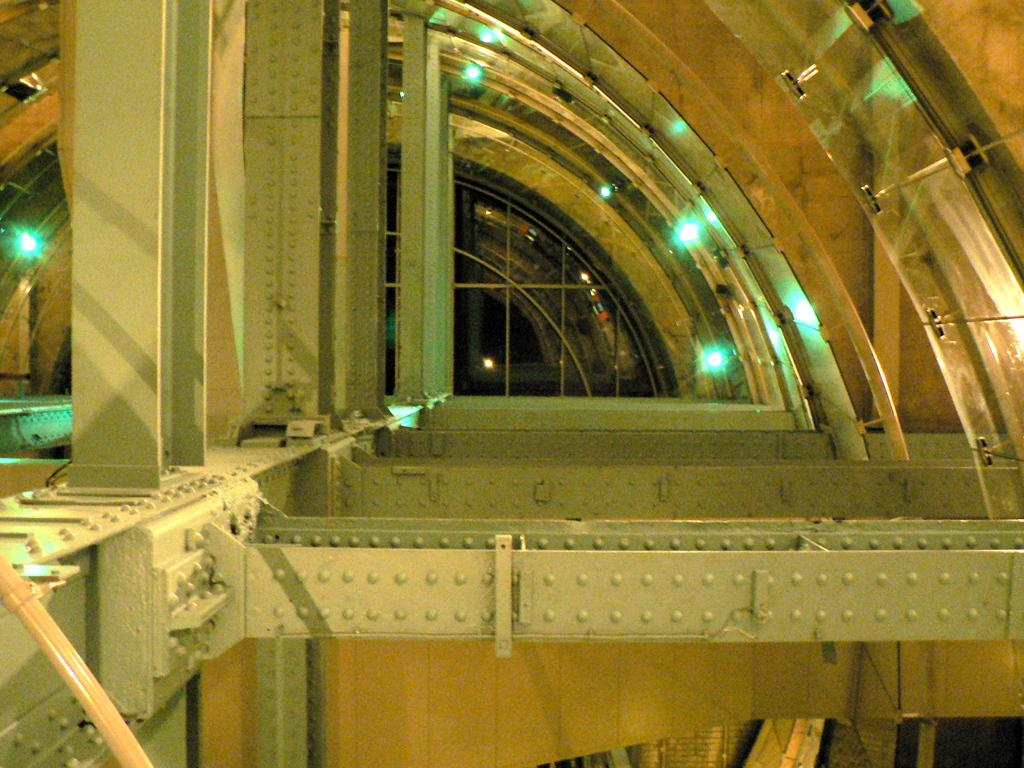Where was the image taken? The image was taken inside a metal chamber. What can be seen in the middle of the chamber? There is a metal frame in the middle of the chamber. Is there a way to enter or exit the chamber? Yes, there is a door in the back of the chamber. What is the tendency of the cast in the image? There is no cast present in the image, so it is not possible to determine any tendencies. 